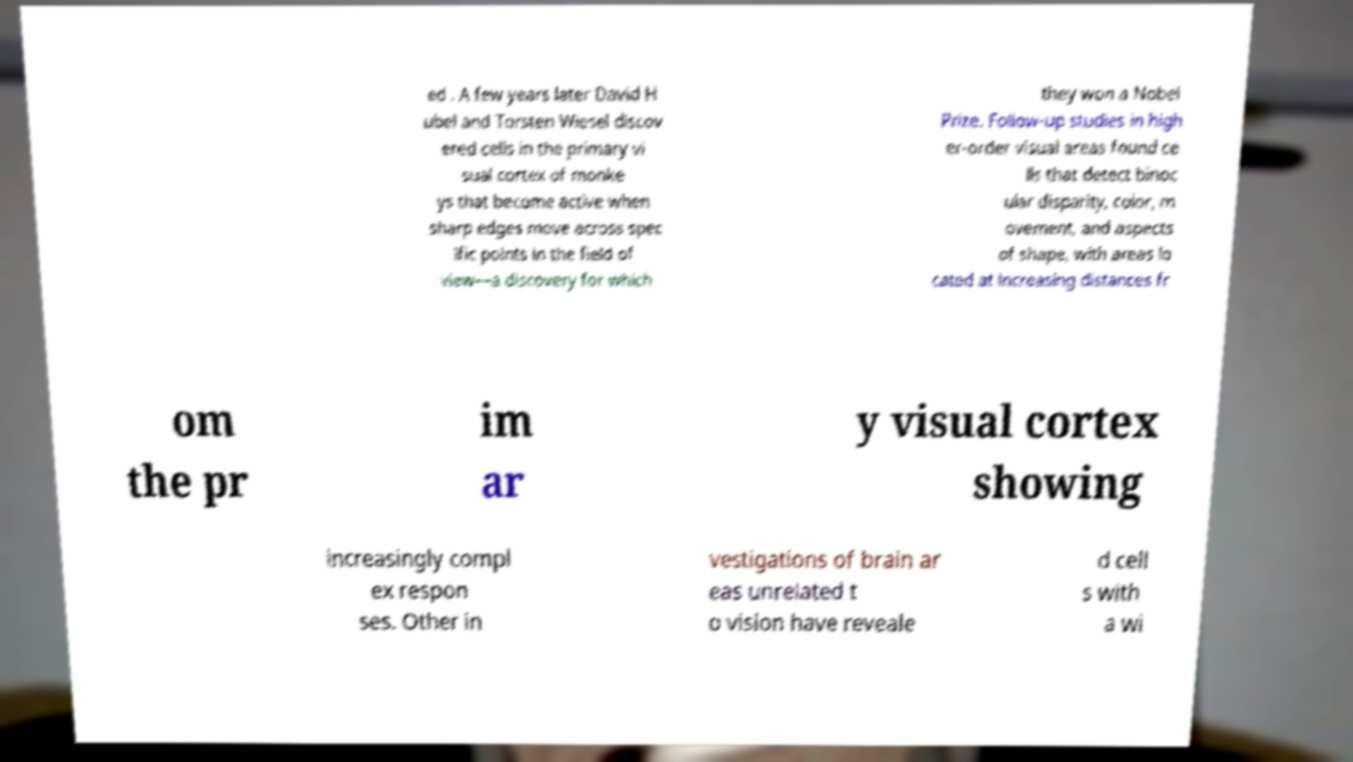For documentation purposes, I need the text within this image transcribed. Could you provide that? ed . A few years later David H ubel and Torsten Wiesel discov ered cells in the primary vi sual cortex of monke ys that become active when sharp edges move across spec ific points in the field of view—a discovery for which they won a Nobel Prize. Follow-up studies in high er-order visual areas found ce lls that detect binoc ular disparity, color, m ovement, and aspects of shape, with areas lo cated at increasing distances fr om the pr im ar y visual cortex showing increasingly compl ex respon ses. Other in vestigations of brain ar eas unrelated t o vision have reveale d cell s with a wi 